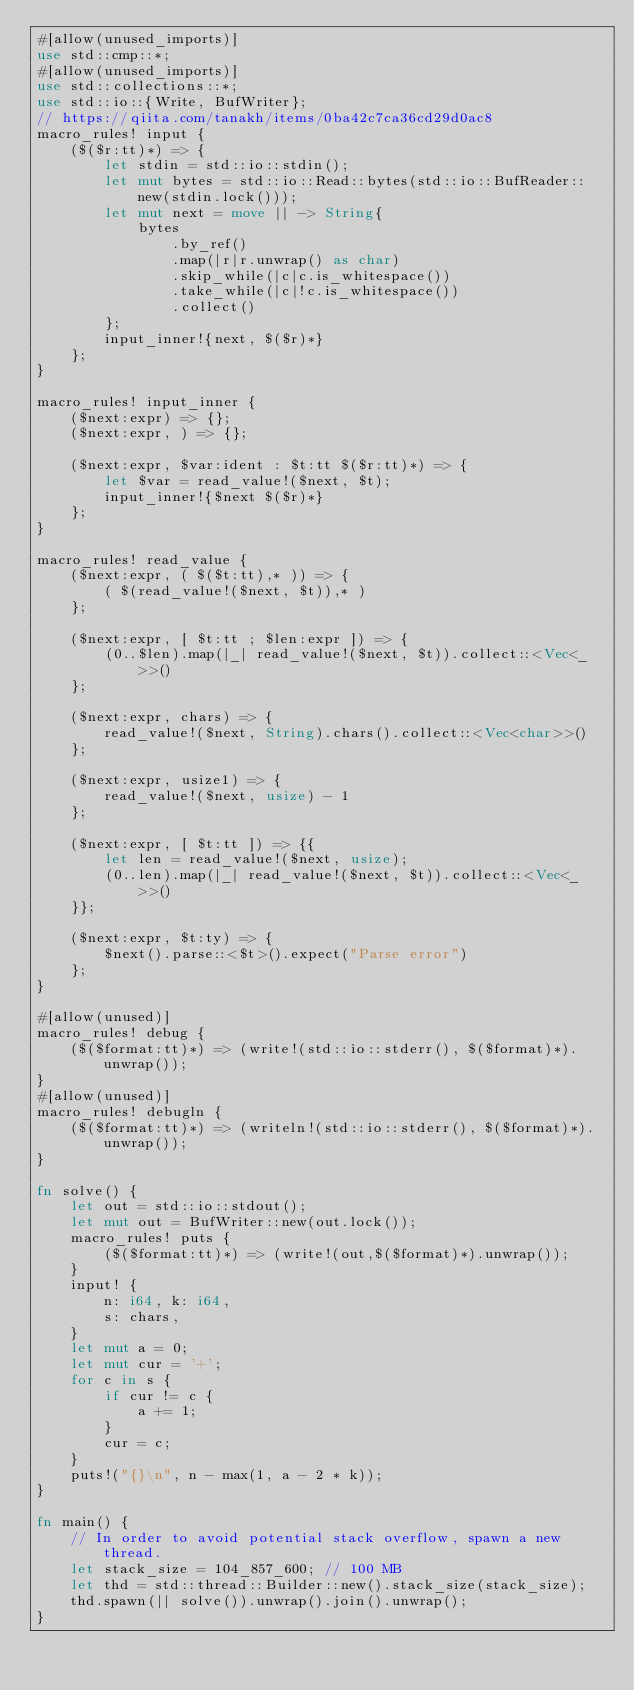<code> <loc_0><loc_0><loc_500><loc_500><_Rust_>#[allow(unused_imports)]
use std::cmp::*;
#[allow(unused_imports)]
use std::collections::*;
use std::io::{Write, BufWriter};
// https://qiita.com/tanakh/items/0ba42c7ca36cd29d0ac8
macro_rules! input {
    ($($r:tt)*) => {
        let stdin = std::io::stdin();
        let mut bytes = std::io::Read::bytes(std::io::BufReader::new(stdin.lock()));
        let mut next = move || -> String{
            bytes
                .by_ref()
                .map(|r|r.unwrap() as char)
                .skip_while(|c|c.is_whitespace())
                .take_while(|c|!c.is_whitespace())
                .collect()
        };
        input_inner!{next, $($r)*}
    };
}

macro_rules! input_inner {
    ($next:expr) => {};
    ($next:expr, ) => {};

    ($next:expr, $var:ident : $t:tt $($r:tt)*) => {
        let $var = read_value!($next, $t);
        input_inner!{$next $($r)*}
    };
}

macro_rules! read_value {
    ($next:expr, ( $($t:tt),* )) => {
        ( $(read_value!($next, $t)),* )
    };

    ($next:expr, [ $t:tt ; $len:expr ]) => {
        (0..$len).map(|_| read_value!($next, $t)).collect::<Vec<_>>()
    };

    ($next:expr, chars) => {
        read_value!($next, String).chars().collect::<Vec<char>>()
    };

    ($next:expr, usize1) => {
        read_value!($next, usize) - 1
    };

    ($next:expr, [ $t:tt ]) => {{
        let len = read_value!($next, usize);
        (0..len).map(|_| read_value!($next, $t)).collect::<Vec<_>>()
    }};

    ($next:expr, $t:ty) => {
        $next().parse::<$t>().expect("Parse error")
    };
}

#[allow(unused)]
macro_rules! debug {
    ($($format:tt)*) => (write!(std::io::stderr(), $($format)*).unwrap());
}
#[allow(unused)]
macro_rules! debugln {
    ($($format:tt)*) => (writeln!(std::io::stderr(), $($format)*).unwrap());
}

fn solve() {
    let out = std::io::stdout();
    let mut out = BufWriter::new(out.lock());
    macro_rules! puts {
        ($($format:tt)*) => (write!(out,$($format)*).unwrap());
    }
    input! {
        n: i64, k: i64,
        s: chars,
    }
    let mut a = 0;
    let mut cur = '+';
    for c in s {
        if cur != c {
            a += 1;
        }
        cur = c;
    }
    puts!("{}\n", n - max(1, a - 2 * k));
}

fn main() {
    // In order to avoid potential stack overflow, spawn a new thread.
    let stack_size = 104_857_600; // 100 MB
    let thd = std::thread::Builder::new().stack_size(stack_size);
    thd.spawn(|| solve()).unwrap().join().unwrap();
}
</code> 